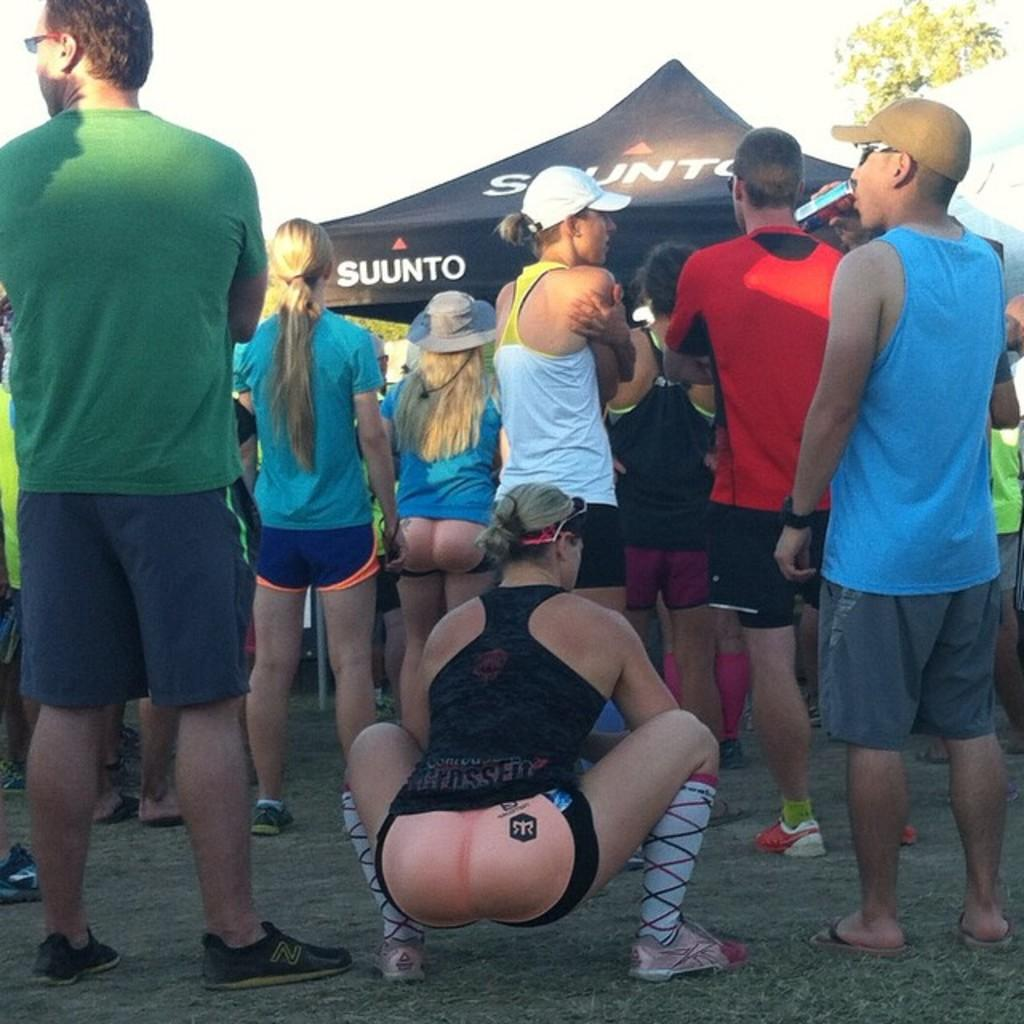<image>
Write a terse but informative summary of the picture. Suunto sponsored the festival at which the people are gathered. 